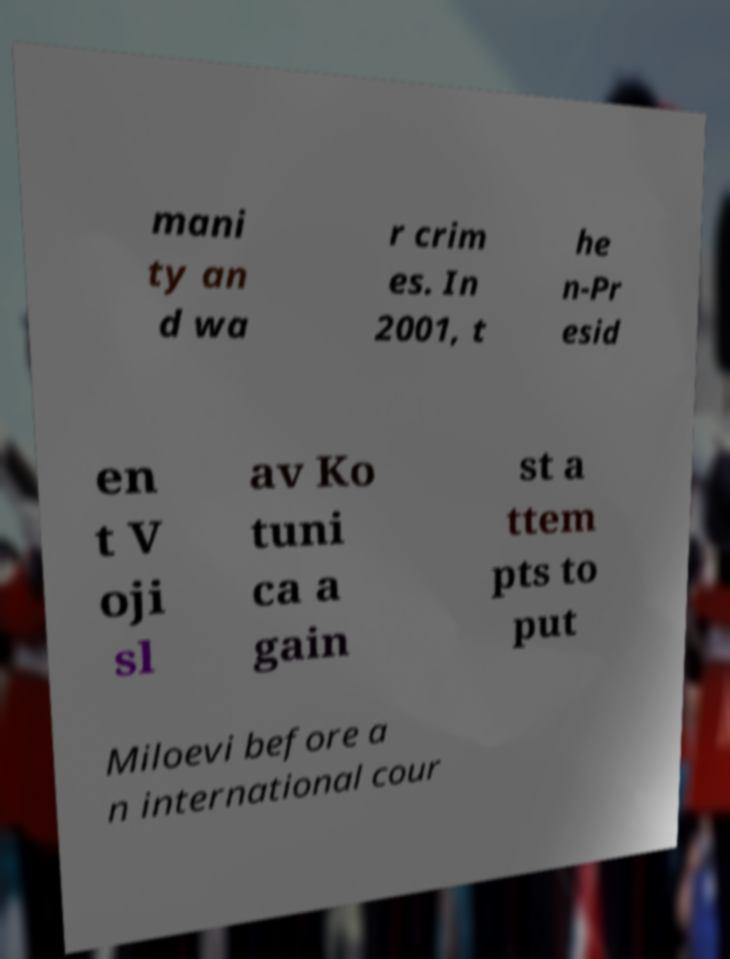For documentation purposes, I need the text within this image transcribed. Could you provide that? mani ty an d wa r crim es. In 2001, t he n-Pr esid en t V oji sl av Ko tuni ca a gain st a ttem pts to put Miloevi before a n international cour 